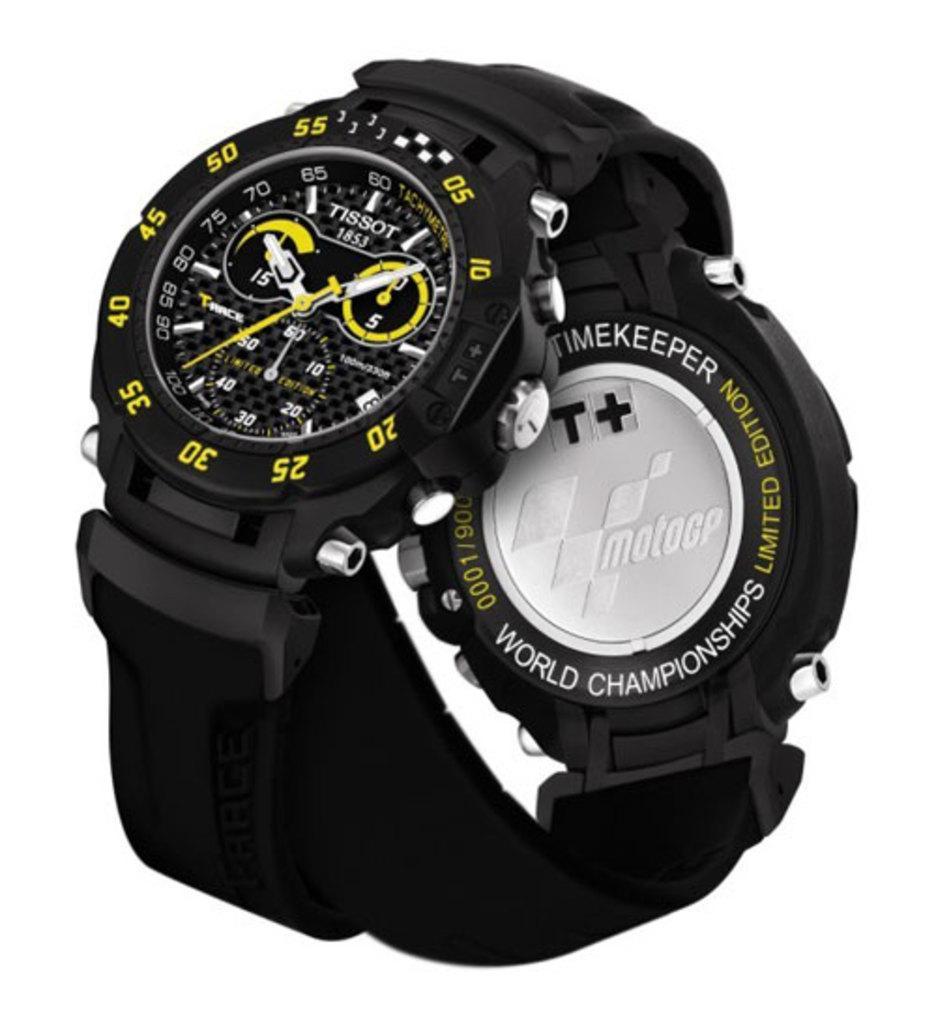Can you describe this image briefly? There is a black color watch having yellow color numbers on the surface of the border. And the background is white in color. 